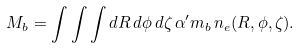Convert formula to latex. <formula><loc_0><loc_0><loc_500><loc_500>M _ { b } = \int \int \int d R \, d \phi \, d \zeta \, \alpha ^ { \prime } m _ { b } \, n _ { e } ( R , \phi , \zeta ) .</formula> 